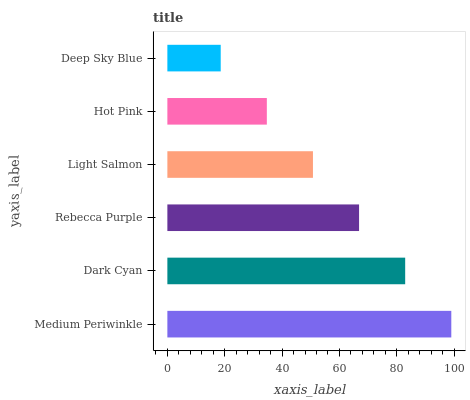Is Deep Sky Blue the minimum?
Answer yes or no. Yes. Is Medium Periwinkle the maximum?
Answer yes or no. Yes. Is Dark Cyan the minimum?
Answer yes or no. No. Is Dark Cyan the maximum?
Answer yes or no. No. Is Medium Periwinkle greater than Dark Cyan?
Answer yes or no. Yes. Is Dark Cyan less than Medium Periwinkle?
Answer yes or no. Yes. Is Dark Cyan greater than Medium Periwinkle?
Answer yes or no. No. Is Medium Periwinkle less than Dark Cyan?
Answer yes or no. No. Is Rebecca Purple the high median?
Answer yes or no. Yes. Is Light Salmon the low median?
Answer yes or no. Yes. Is Hot Pink the high median?
Answer yes or no. No. Is Hot Pink the low median?
Answer yes or no. No. 